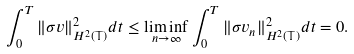<formula> <loc_0><loc_0><loc_500><loc_500>\int _ { 0 } ^ { T } \| \sigma v \| _ { H ^ { 2 } ( \mathbb { T } ) } ^ { 2 } d t \leq \liminf _ { n \rightarrow \infty } \int _ { 0 } ^ { T } \| \sigma v _ { n } \| _ { H ^ { 2 } ( \mathbb { T } ) } ^ { 2 } d t = 0 .</formula> 